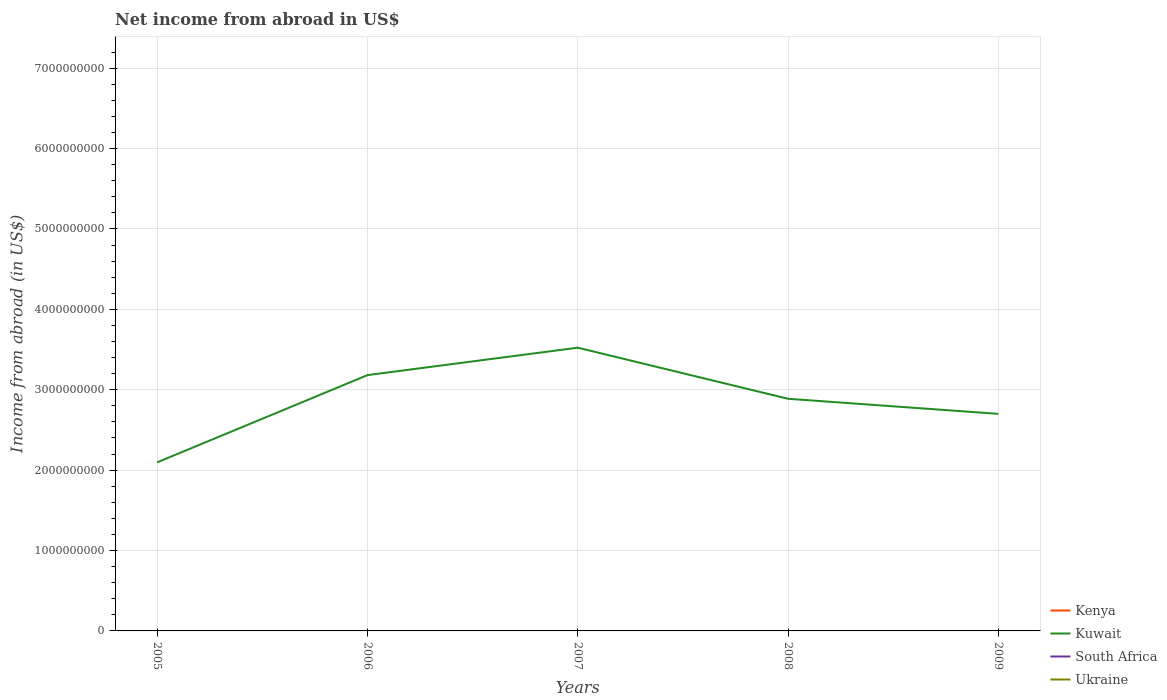Is the number of lines equal to the number of legend labels?
Keep it short and to the point. No. Across all years, what is the maximum net income from abroad in Ukraine?
Keep it short and to the point. 0. What is the total net income from abroad in Kuwait in the graph?
Provide a succinct answer. -1.43e+09. How many lines are there?
Offer a very short reply. 1. How many years are there in the graph?
Offer a terse response. 5. What is the difference between two consecutive major ticks on the Y-axis?
Provide a succinct answer. 1.00e+09. How many legend labels are there?
Offer a terse response. 4. How are the legend labels stacked?
Ensure brevity in your answer.  Vertical. What is the title of the graph?
Keep it short and to the point. Net income from abroad in US$. What is the label or title of the X-axis?
Ensure brevity in your answer.  Years. What is the label or title of the Y-axis?
Your answer should be compact. Income from abroad (in US$). What is the Income from abroad (in US$) of Kuwait in 2005?
Provide a succinct answer. 2.10e+09. What is the Income from abroad (in US$) of Kuwait in 2006?
Ensure brevity in your answer.  3.18e+09. What is the Income from abroad (in US$) of Kuwait in 2007?
Give a very brief answer. 3.52e+09. What is the Income from abroad (in US$) in South Africa in 2007?
Provide a short and direct response. 0. What is the Income from abroad (in US$) in Ukraine in 2007?
Your answer should be very brief. 0. What is the Income from abroad (in US$) in Kuwait in 2008?
Provide a succinct answer. 2.89e+09. What is the Income from abroad (in US$) in South Africa in 2008?
Provide a short and direct response. 0. What is the Income from abroad (in US$) in Ukraine in 2008?
Give a very brief answer. 0. What is the Income from abroad (in US$) of Kenya in 2009?
Offer a very short reply. 0. What is the Income from abroad (in US$) in Kuwait in 2009?
Keep it short and to the point. 2.70e+09. What is the Income from abroad (in US$) in Ukraine in 2009?
Provide a succinct answer. 0. Across all years, what is the maximum Income from abroad (in US$) in Kuwait?
Ensure brevity in your answer.  3.52e+09. Across all years, what is the minimum Income from abroad (in US$) of Kuwait?
Offer a terse response. 2.10e+09. What is the total Income from abroad (in US$) of Kenya in the graph?
Your answer should be compact. 0. What is the total Income from abroad (in US$) of Kuwait in the graph?
Your response must be concise. 1.44e+1. What is the total Income from abroad (in US$) in South Africa in the graph?
Offer a terse response. 0. What is the total Income from abroad (in US$) of Ukraine in the graph?
Keep it short and to the point. 0. What is the difference between the Income from abroad (in US$) in Kuwait in 2005 and that in 2006?
Your answer should be very brief. -1.08e+09. What is the difference between the Income from abroad (in US$) in Kuwait in 2005 and that in 2007?
Give a very brief answer. -1.43e+09. What is the difference between the Income from abroad (in US$) of Kuwait in 2005 and that in 2008?
Make the answer very short. -7.91e+08. What is the difference between the Income from abroad (in US$) of Kuwait in 2005 and that in 2009?
Keep it short and to the point. -6.03e+08. What is the difference between the Income from abroad (in US$) in Kuwait in 2006 and that in 2007?
Offer a very short reply. -3.41e+08. What is the difference between the Income from abroad (in US$) in Kuwait in 2006 and that in 2008?
Give a very brief answer. 2.94e+08. What is the difference between the Income from abroad (in US$) of Kuwait in 2006 and that in 2009?
Your answer should be compact. 4.82e+08. What is the difference between the Income from abroad (in US$) of Kuwait in 2007 and that in 2008?
Ensure brevity in your answer.  6.35e+08. What is the difference between the Income from abroad (in US$) in Kuwait in 2007 and that in 2009?
Your answer should be compact. 8.23e+08. What is the difference between the Income from abroad (in US$) in Kuwait in 2008 and that in 2009?
Make the answer very short. 1.88e+08. What is the average Income from abroad (in US$) in Kenya per year?
Make the answer very short. 0. What is the average Income from abroad (in US$) in Kuwait per year?
Offer a terse response. 2.88e+09. What is the ratio of the Income from abroad (in US$) in Kuwait in 2005 to that in 2006?
Ensure brevity in your answer.  0.66. What is the ratio of the Income from abroad (in US$) of Kuwait in 2005 to that in 2007?
Offer a terse response. 0.6. What is the ratio of the Income from abroad (in US$) in Kuwait in 2005 to that in 2008?
Make the answer very short. 0.73. What is the ratio of the Income from abroad (in US$) in Kuwait in 2005 to that in 2009?
Give a very brief answer. 0.78. What is the ratio of the Income from abroad (in US$) in Kuwait in 2006 to that in 2007?
Offer a very short reply. 0.9. What is the ratio of the Income from abroad (in US$) of Kuwait in 2006 to that in 2008?
Give a very brief answer. 1.1. What is the ratio of the Income from abroad (in US$) in Kuwait in 2006 to that in 2009?
Provide a succinct answer. 1.18. What is the ratio of the Income from abroad (in US$) of Kuwait in 2007 to that in 2008?
Your answer should be compact. 1.22. What is the ratio of the Income from abroad (in US$) in Kuwait in 2007 to that in 2009?
Provide a succinct answer. 1.3. What is the ratio of the Income from abroad (in US$) of Kuwait in 2008 to that in 2009?
Provide a succinct answer. 1.07. What is the difference between the highest and the second highest Income from abroad (in US$) of Kuwait?
Give a very brief answer. 3.41e+08. What is the difference between the highest and the lowest Income from abroad (in US$) in Kuwait?
Provide a succinct answer. 1.43e+09. 